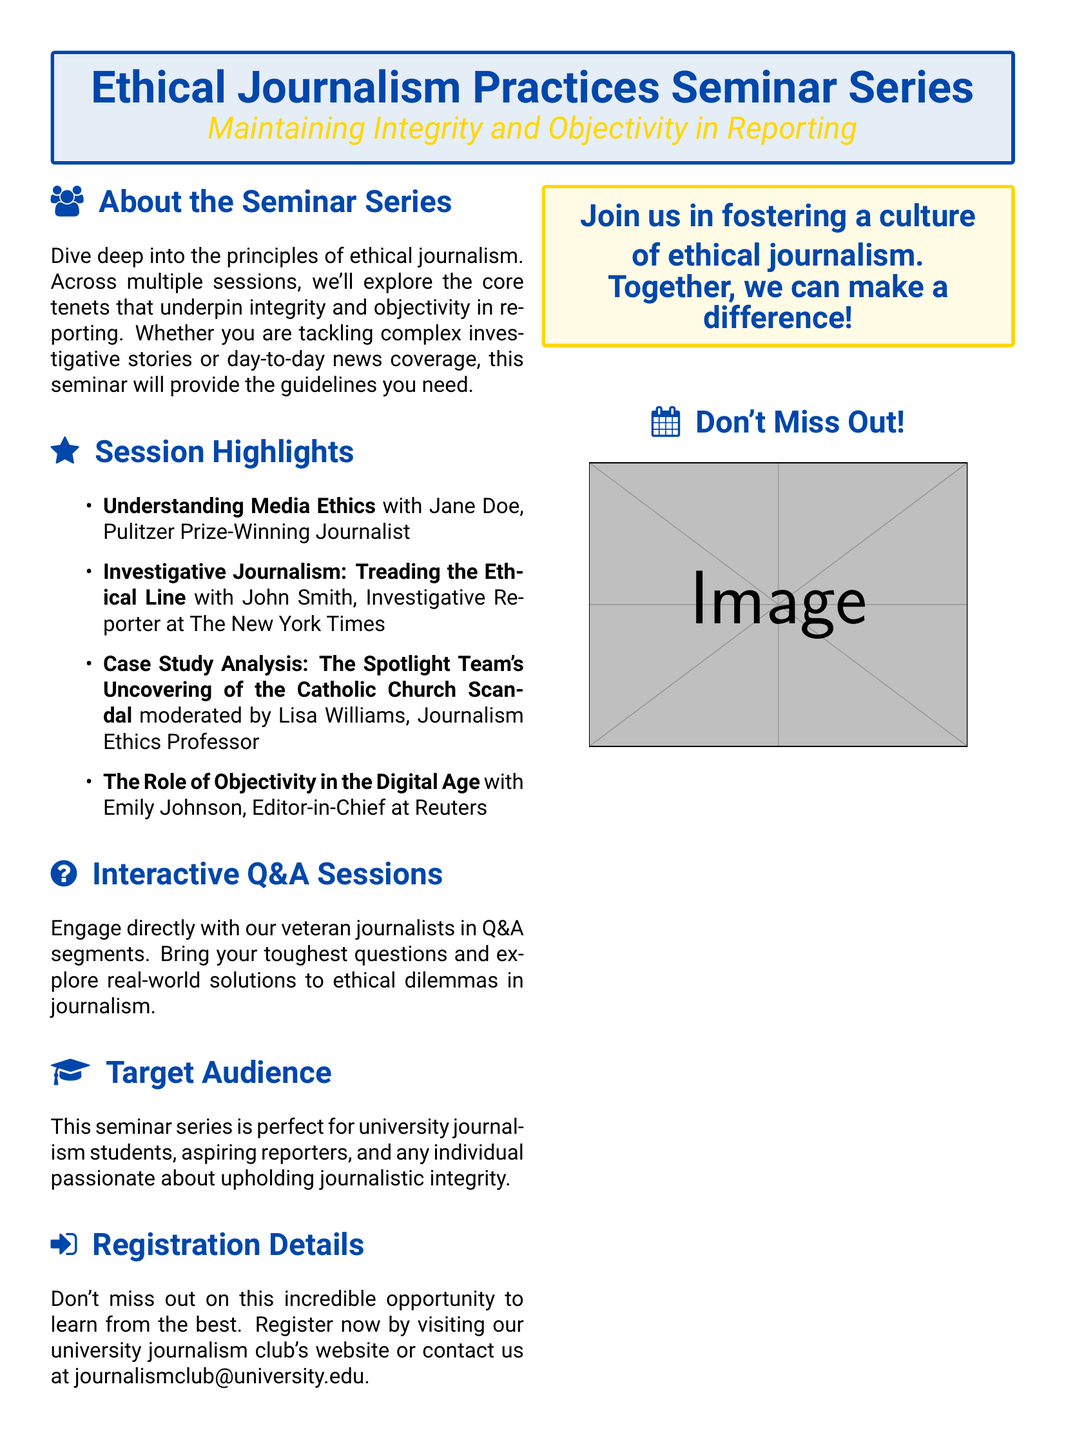What is the title of the seminar series? The title of the seminar series is stated clearly in the document.
Answer: Ethical Journalism Practices Seminar Series Who is the Pulitzer Prize-winning journalist featured in the seminar? The document lists Jane Doe as the featured Pulitzer Prize-winning journalist.
Answer: Jane Doe What subject is covered in the case study analysis? The case study analysis topic is outlined in the session highlights section.
Answer: The Spotlight Team's Uncovering of the Catholic Church Scandal What role does Emily Johnson hold? The document details Emily Johnson's professional role in the seminar highlights section.
Answer: Editor-in-Chief at Reuters How many session highlights are listed? The number of session highlights can be counted in the session highlights section of the document.
Answer: Four What is the target audience for the seminar series? The document specifies who the seminar series is aimed at in the target audience section.
Answer: University journalism students, aspiring reporters, and individuals passionate about upholding journalistic integrity What is the method of registration mentioned? The registration method is described in the registration details section of the document.
Answer: Visiting the university journalism club's website or contacting via email What is the color scheme used for the seminar series title box? The color scheme is detailed in the description of the box containing the title of the seminar series.
Answer: Main color and second color 